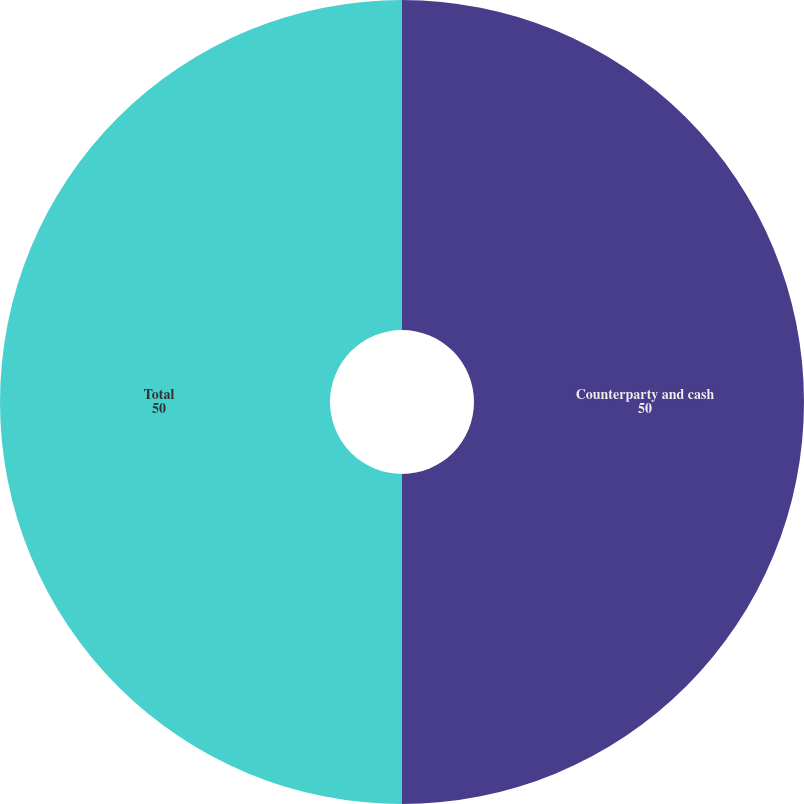<chart> <loc_0><loc_0><loc_500><loc_500><pie_chart><fcel>Counterparty and cash<fcel>Total<nl><fcel>50.0%<fcel>50.0%<nl></chart> 